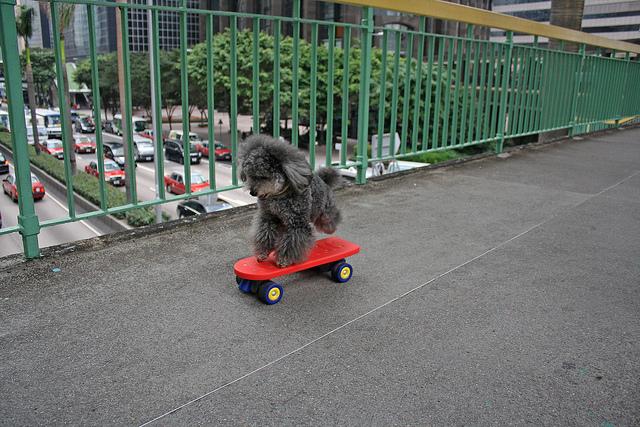Does the dog appear balanced?
Concise answer only. Yes. What is the dog riding?
Answer briefly. Skateboard. What is the color of the railing?
Answer briefly. Green. 